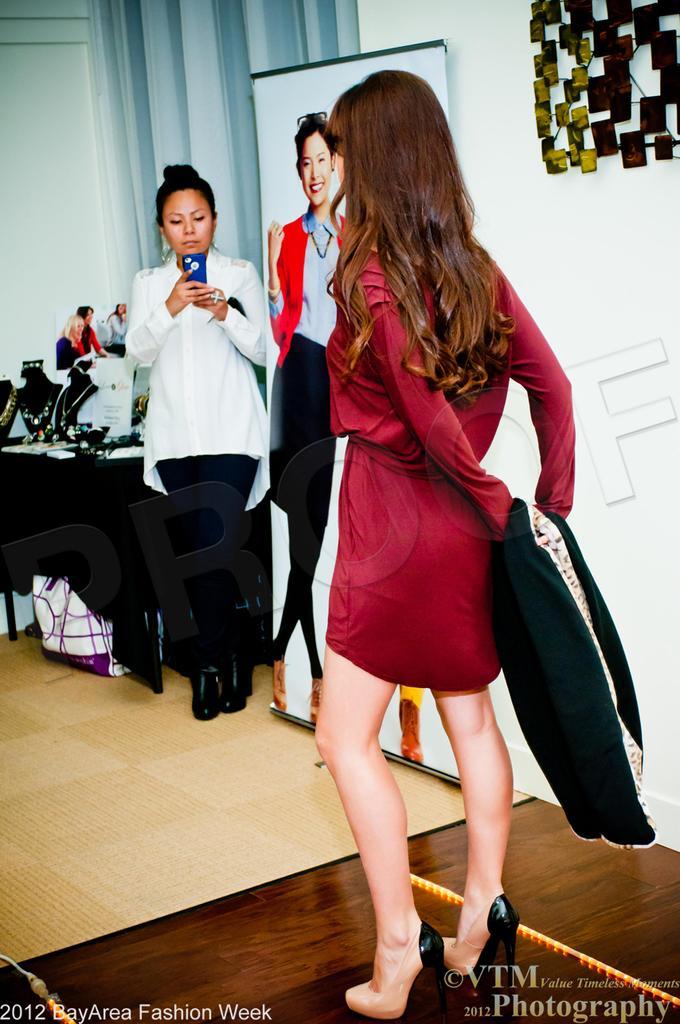Could you give a brief overview of what you see in this image? In the foreground of the picture there is a woman in red dress standing. In the center of the pictures there are jewelry, a woman holding mobile and a banner. On the right there is an object. In the background it is window blind. 